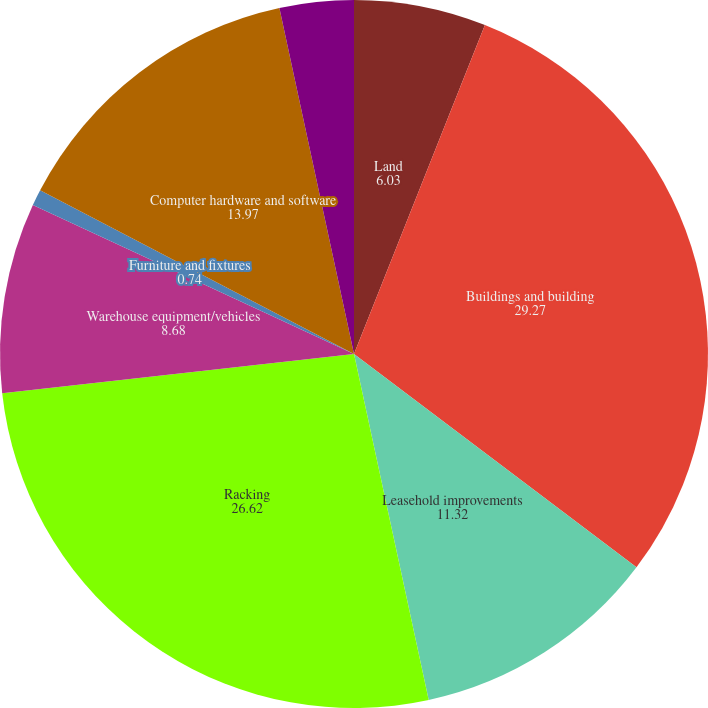Convert chart to OTSL. <chart><loc_0><loc_0><loc_500><loc_500><pie_chart><fcel>Land<fcel>Buildings and building<fcel>Leasehold improvements<fcel>Racking<fcel>Warehouse equipment/vehicles<fcel>Furniture and fixtures<fcel>Computer hardware and software<fcel>Construction in progress<nl><fcel>6.03%<fcel>29.27%<fcel>11.32%<fcel>26.62%<fcel>8.68%<fcel>0.74%<fcel>13.97%<fcel>3.38%<nl></chart> 